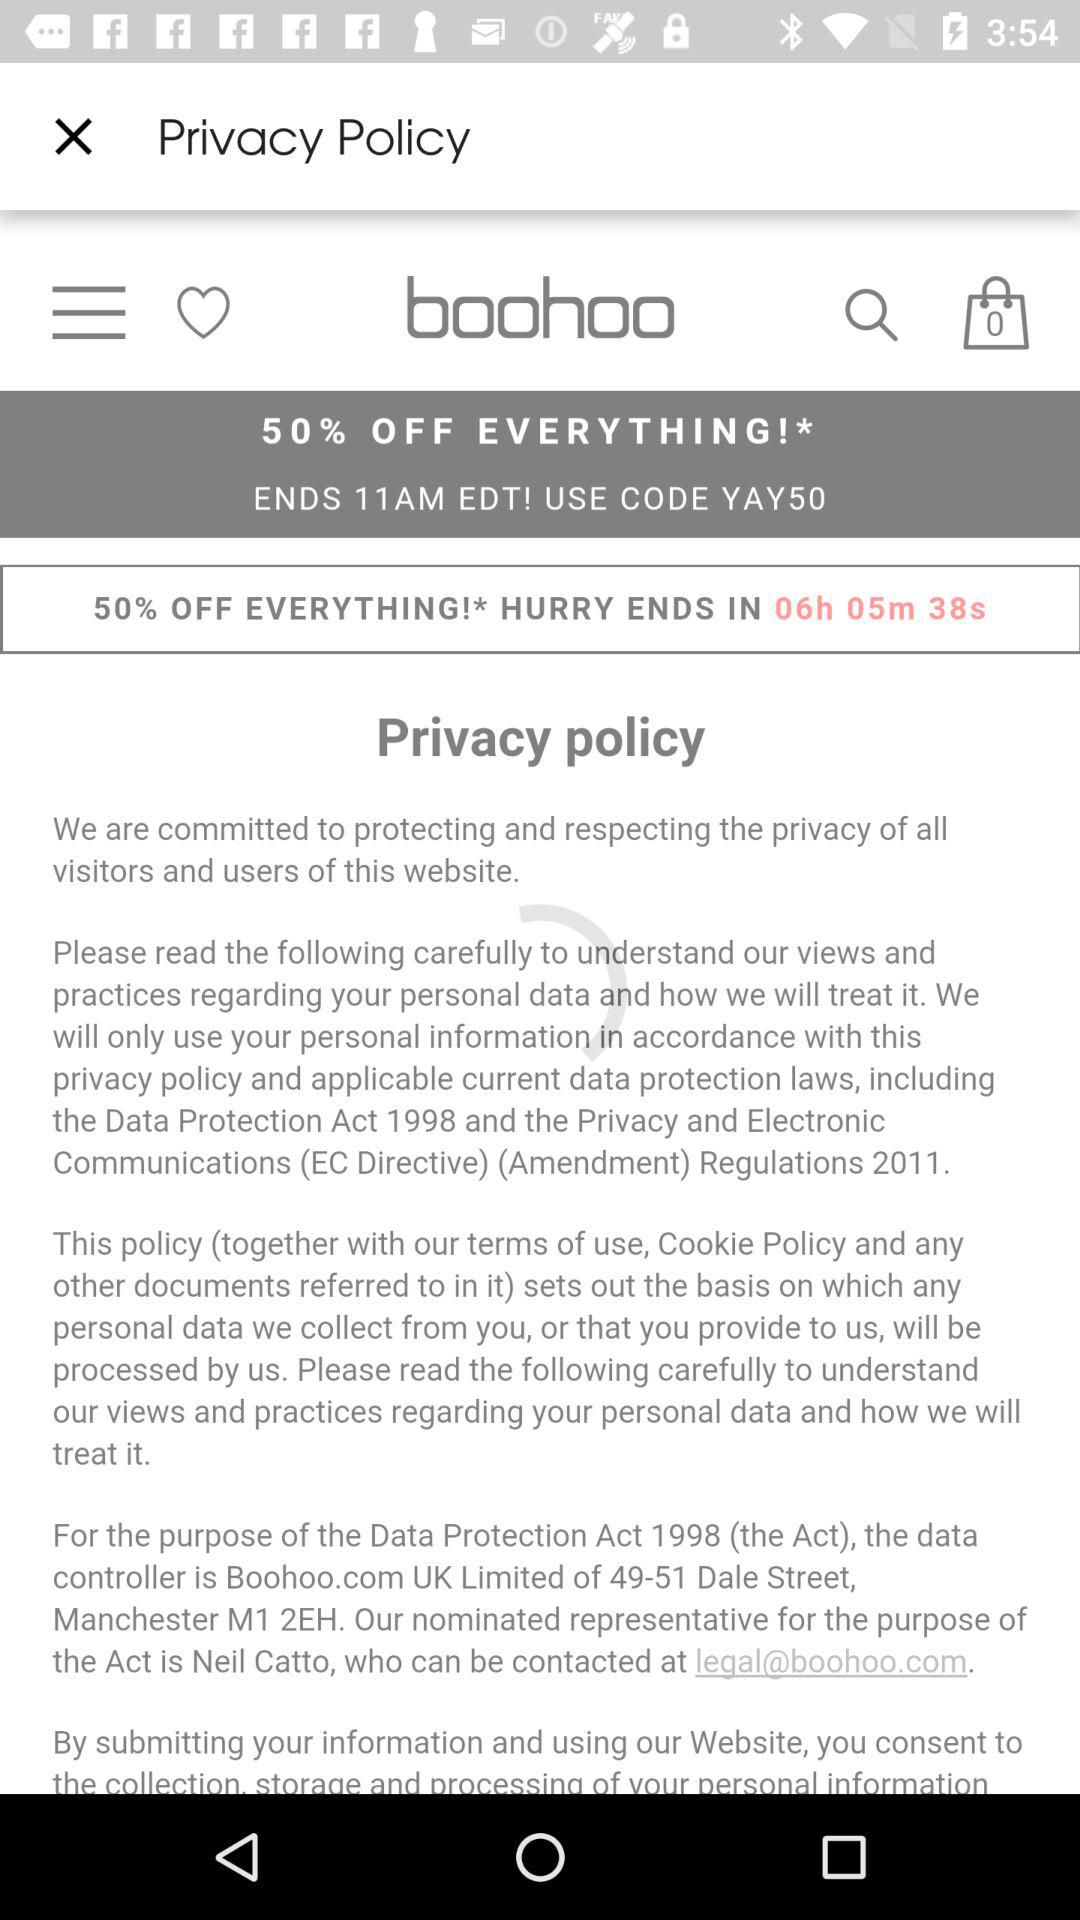How many hours and minutes are left until the sale ends?
Answer the question using a single word or phrase. 6 hours and 5 minutes 